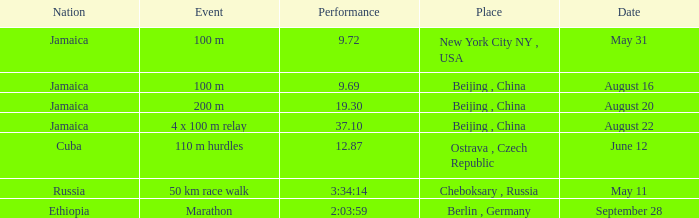What is the Place associated with Cuba? Ostrava , Czech Republic. 